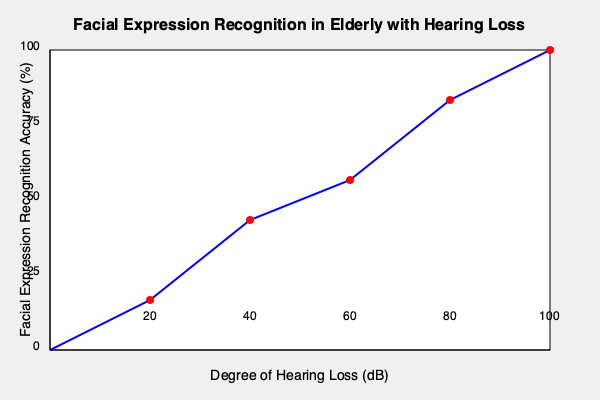Based on the graph, what is the approximate facial expression recognition accuracy for elderly individuals with a hearing loss of 60 dB? To determine the facial expression recognition accuracy for elderly individuals with a hearing loss of 60 dB, we need to follow these steps:

1. Locate the 60 dB mark on the x-axis (Degree of Hearing Loss).
2. This point is represented by the third data point from the left on the graph.
3. Draw an imaginary vertical line from this point up to where it intersects the blue curve.
4. From the intersection point, draw an imaginary horizontal line to the y-axis.
5. Read the corresponding value on the y-axis (Facial Expression Recognition Accuracy).

Following these steps, we can see that the intersection point for 60 dB hearing loss corresponds to approximately 45% facial expression recognition accuracy.

This graph illustrates an inverse relationship between the degree of hearing loss and facial expression recognition accuracy in elderly individuals. As the hearing loss increases, the ability to recognize facial expressions decreases, which is consistent with research showing that sensory deficits can impact cognitive functions, including social cognition.
Answer: 45% 